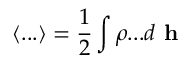Convert formula to latex. <formula><loc_0><loc_0><loc_500><loc_500>\langle \dots \rangle = \frac { 1 } { 2 } \int \rho \dots d h</formula> 